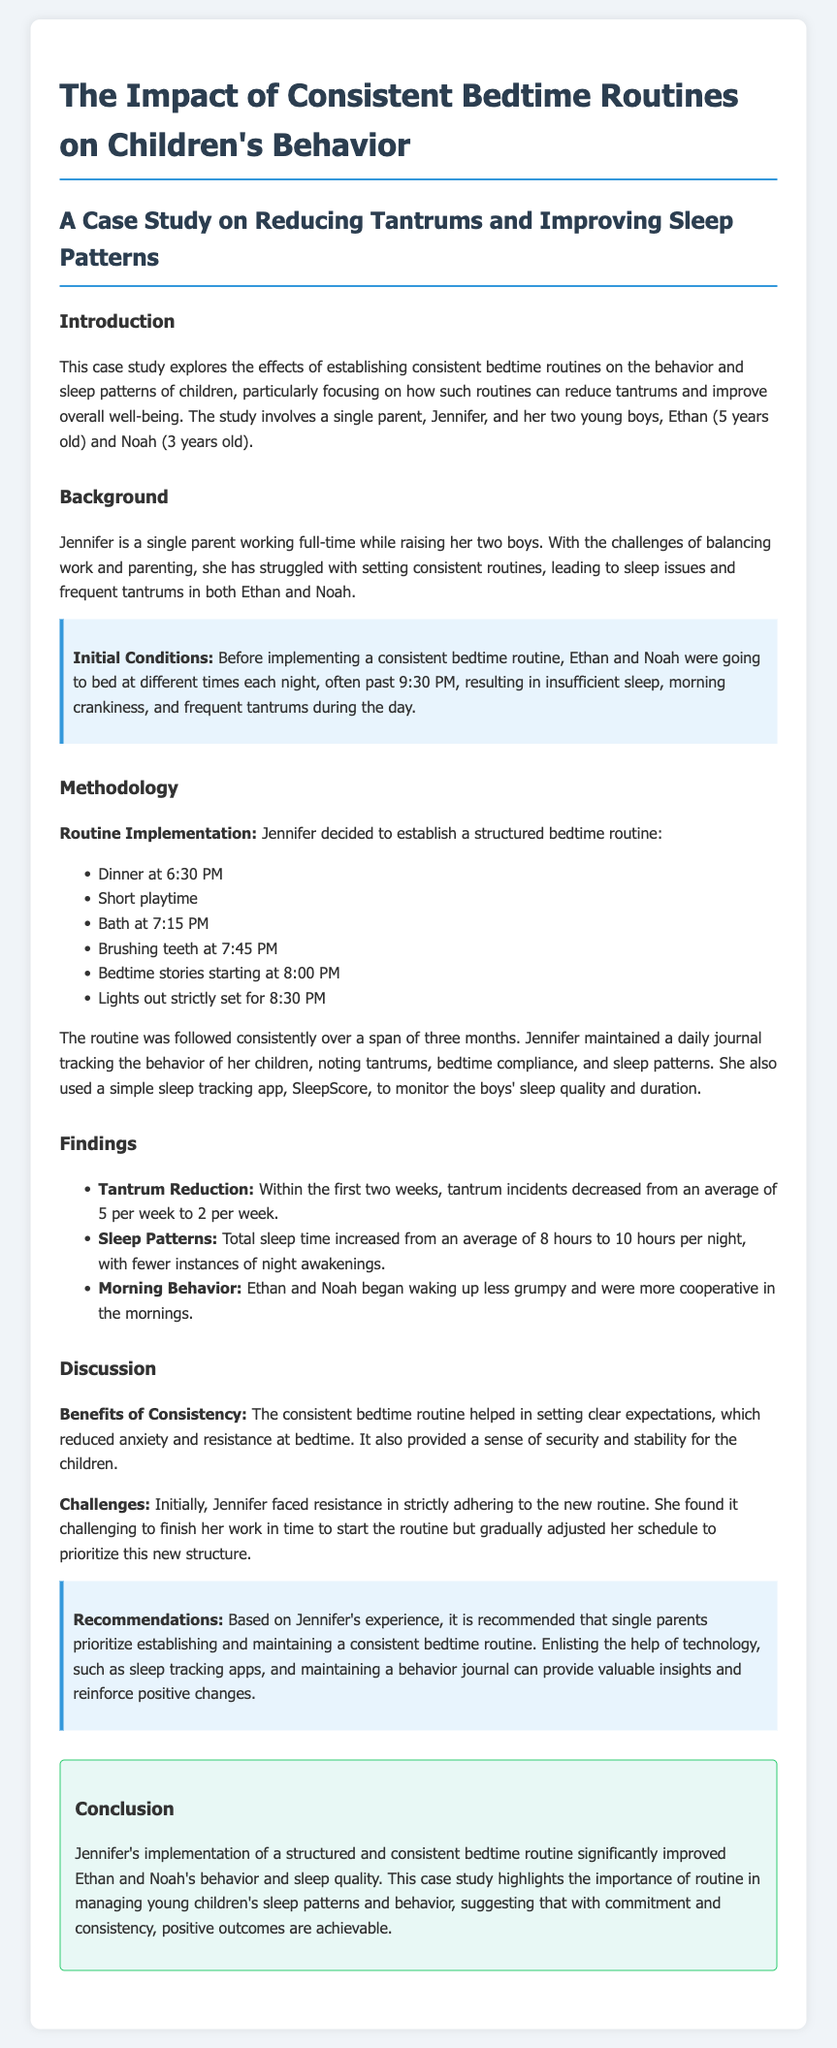what is the average number of tantrums per week before the routine? The average number of tantrums before the routine was measured at five incidents per week.
Answer: 5 what time was bedtime set for after the routine implementation? The bedtime was strictly set for 8:30 PM after implementing the routine.
Answer: 8:30 PM who is the parent in the case study? Jennifer is identified as the parent raising her two boys in the case study.
Answer: Jennifer how long was the routine followed? The consistent bedtime routine was followed over a span of three months.
Answer: three months what improvement was noted in sleep duration? The total sleep time increased from an average of 8 hours to 10 hours per night.
Answer: 10 hours what were the children's names? The names of the children in the case study are Ethan and Noah.
Answer: Ethan and Noah what initial condition led to tantrums? Going to bed at different times each night often past 9:30 PM resulted in insufficient sleep, leading to tantrums.
Answer: different times past 9:30 PM what was a challenge Jennifer faced with the routine? Jennifer faced resistance in strictly adhering to the new routine.
Answer: resistance what was the key recommendation based on the study? It is recommended that single parents prioritize establishing and maintaining a consistent bedtime routine.
Answer: consistent bedtime routine 